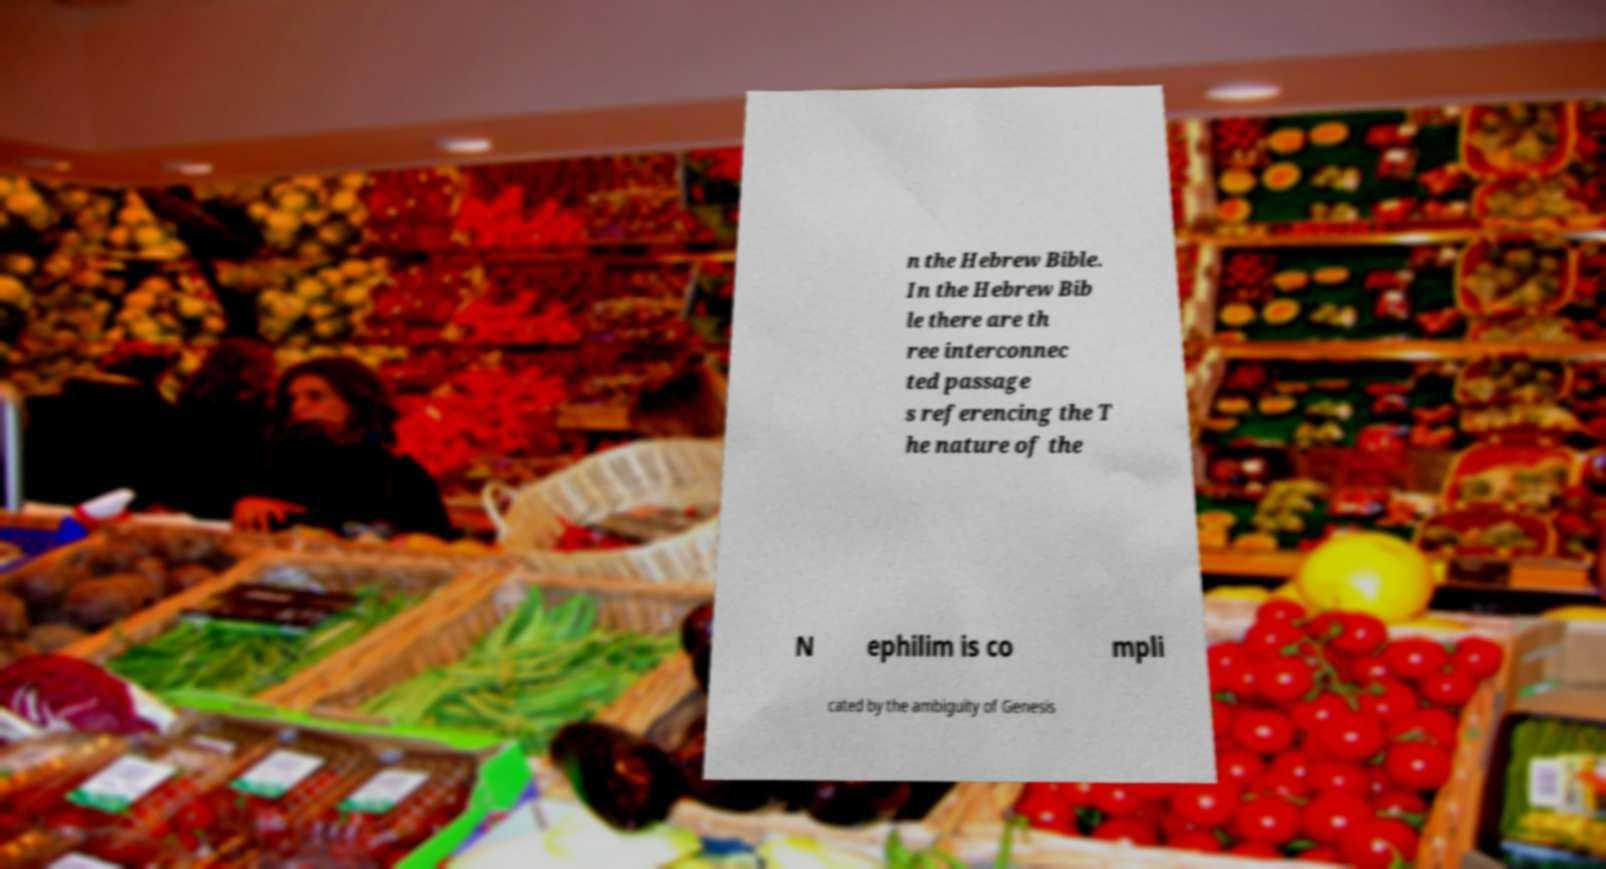Can you accurately transcribe the text from the provided image for me? n the Hebrew Bible. In the Hebrew Bib le there are th ree interconnec ted passage s referencing the T he nature of the N ephilim is co mpli cated by the ambiguity of Genesis 